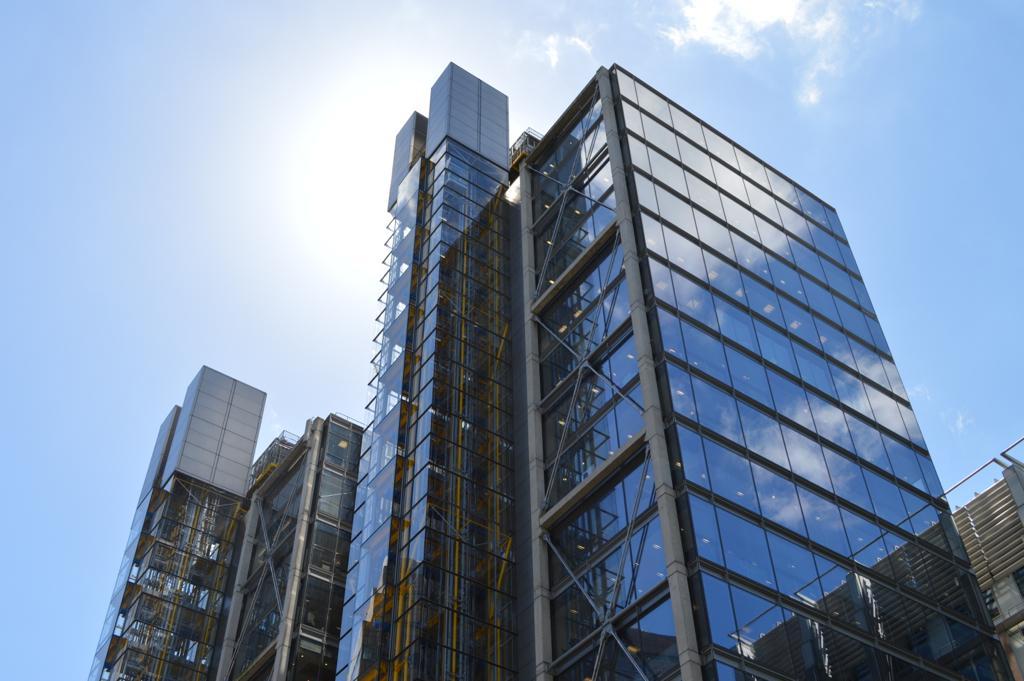Could you give a brief overview of what you see in this image? This picture might be taken from outside of the building and it is sunny. In the background, we can see a sky. 